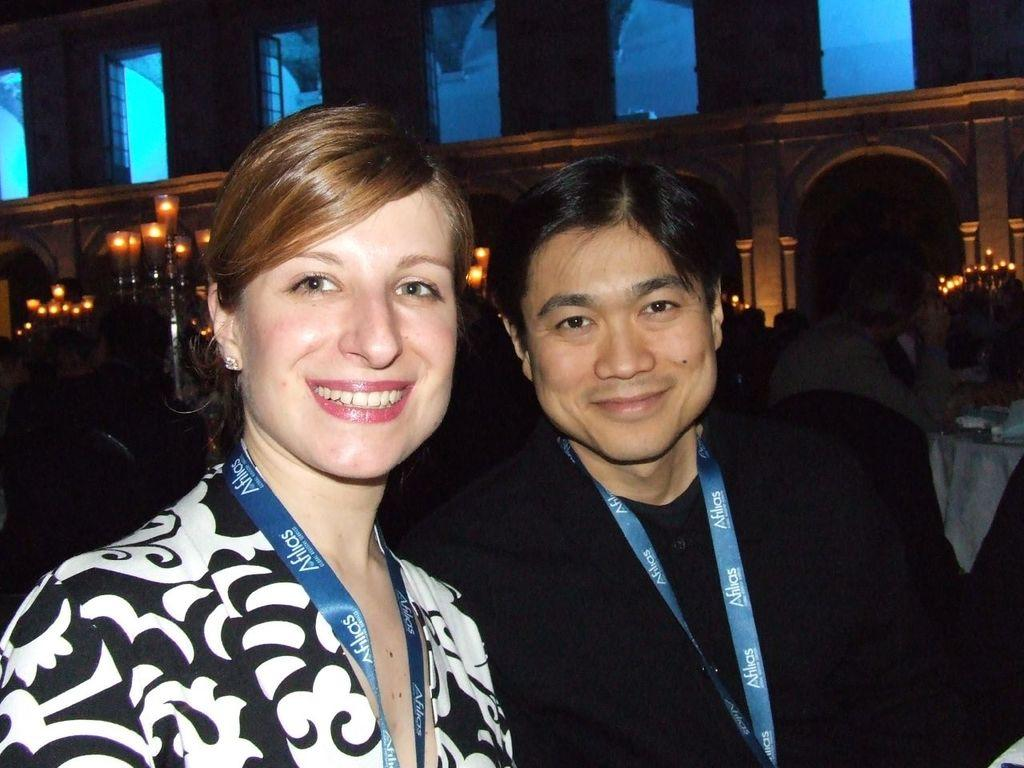What colors are the people wearing in the image? The people in the image are wearing white and black color dresses. What can be seen illuminating the scene in the image? There are lights visible in the image. What is the background of the image made of? There is a wall in the image. What else is present in the image besides the people and the wall? There are objects around in the image. How would you describe the overall lighting in the image? The image is dark. What month is the theory being discussed by the servant in the image? There is no servant or theory present in the image, and therefore no such discussion can be observed. 